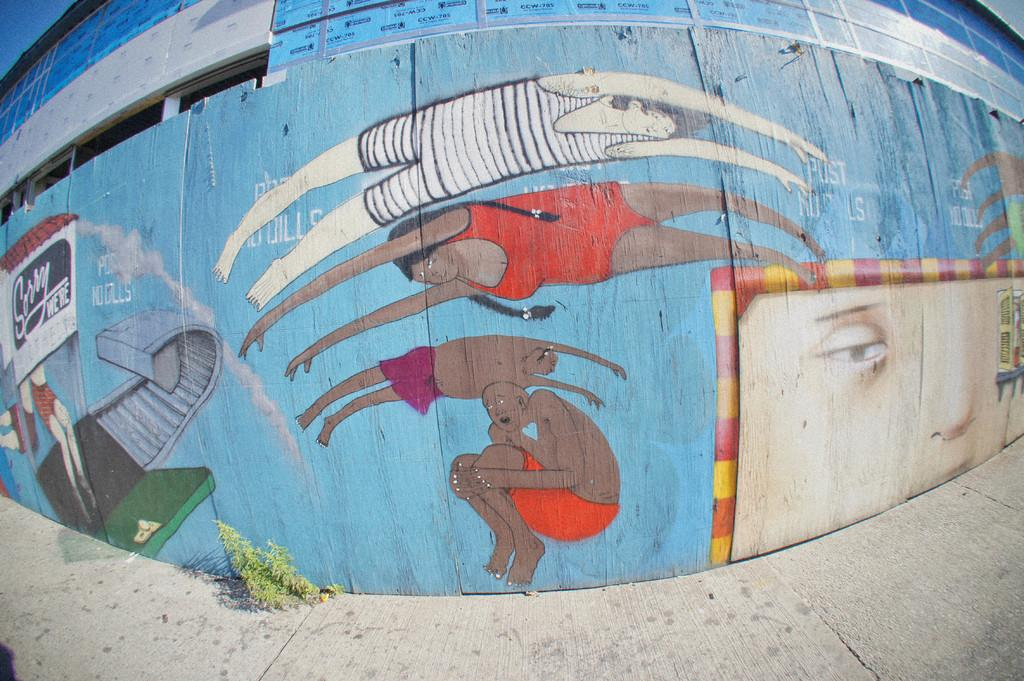What is depicted on the wall in the foreground of the image? There are paintings on a wall in the foreground of the image. What type of structure does the wall belong to? The wall is part of a building. What is at the bottom of the image? There is a pavement at the bottom of the image. Are there any plants visible in the image? Yes, there is a plant near the pavement. What part of the natural environment can be seen in the image? The sky is visible at the top left of the image. How many men are observing the liquid in the image? There is no liquid or men present in the image. What type of observation is being made in the image? There is no observation being made in the image; it features paintings on a wall, a building, a pavement, a plant, and the sky. 